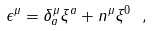Convert formula to latex. <formula><loc_0><loc_0><loc_500><loc_500>\epsilon ^ { \mu } = \delta ^ { \mu } _ { a } \xi ^ { a } + n ^ { \mu } \xi ^ { 0 } \ ,</formula> 